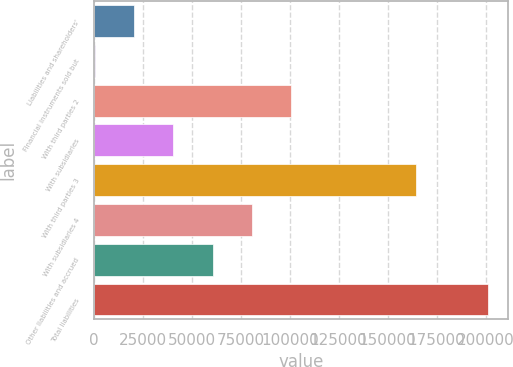<chart> <loc_0><loc_0><loc_500><loc_500><bar_chart><fcel>Liabilities and shareholders'<fcel>Financial instruments sold but<fcel>With third parties 2<fcel>With subsidiaries<fcel>With third parties 3<fcel>With subsidiaries 4<fcel>Other liabilities and accrued<fcel>Total liabilities<nl><fcel>20531.5<fcel>443<fcel>100886<fcel>40620<fcel>164718<fcel>80797<fcel>60708.5<fcel>201328<nl></chart> 